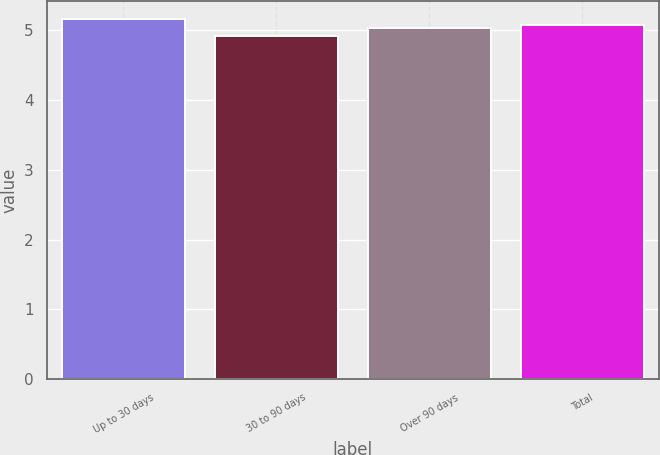Convert chart to OTSL. <chart><loc_0><loc_0><loc_500><loc_500><bar_chart><fcel>Up to 30 days<fcel>30 to 90 days<fcel>Over 90 days<fcel>Total<nl><fcel>5.16<fcel>4.92<fcel>5.03<fcel>5.08<nl></chart> 